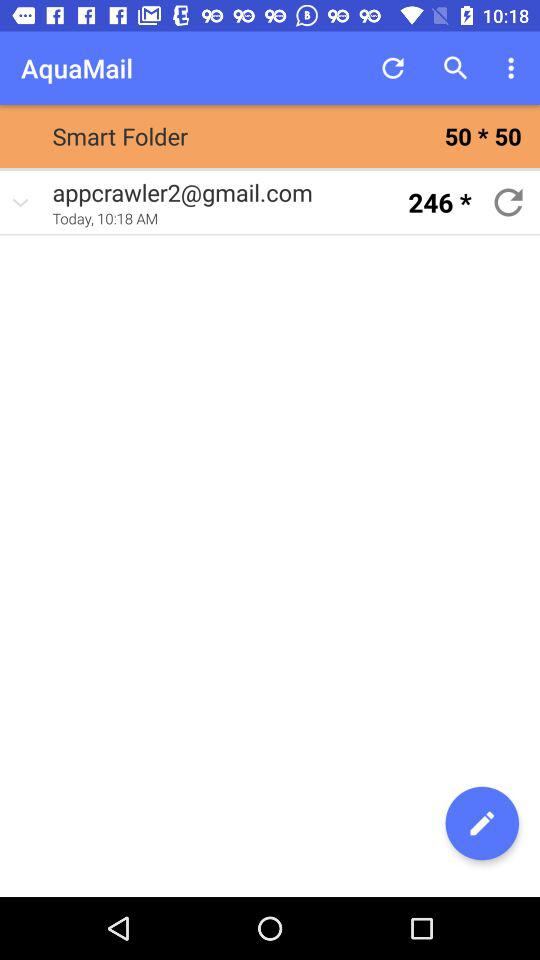What's the Google Mail address? The Google Mail address is appcrawler2@gmail.com. 